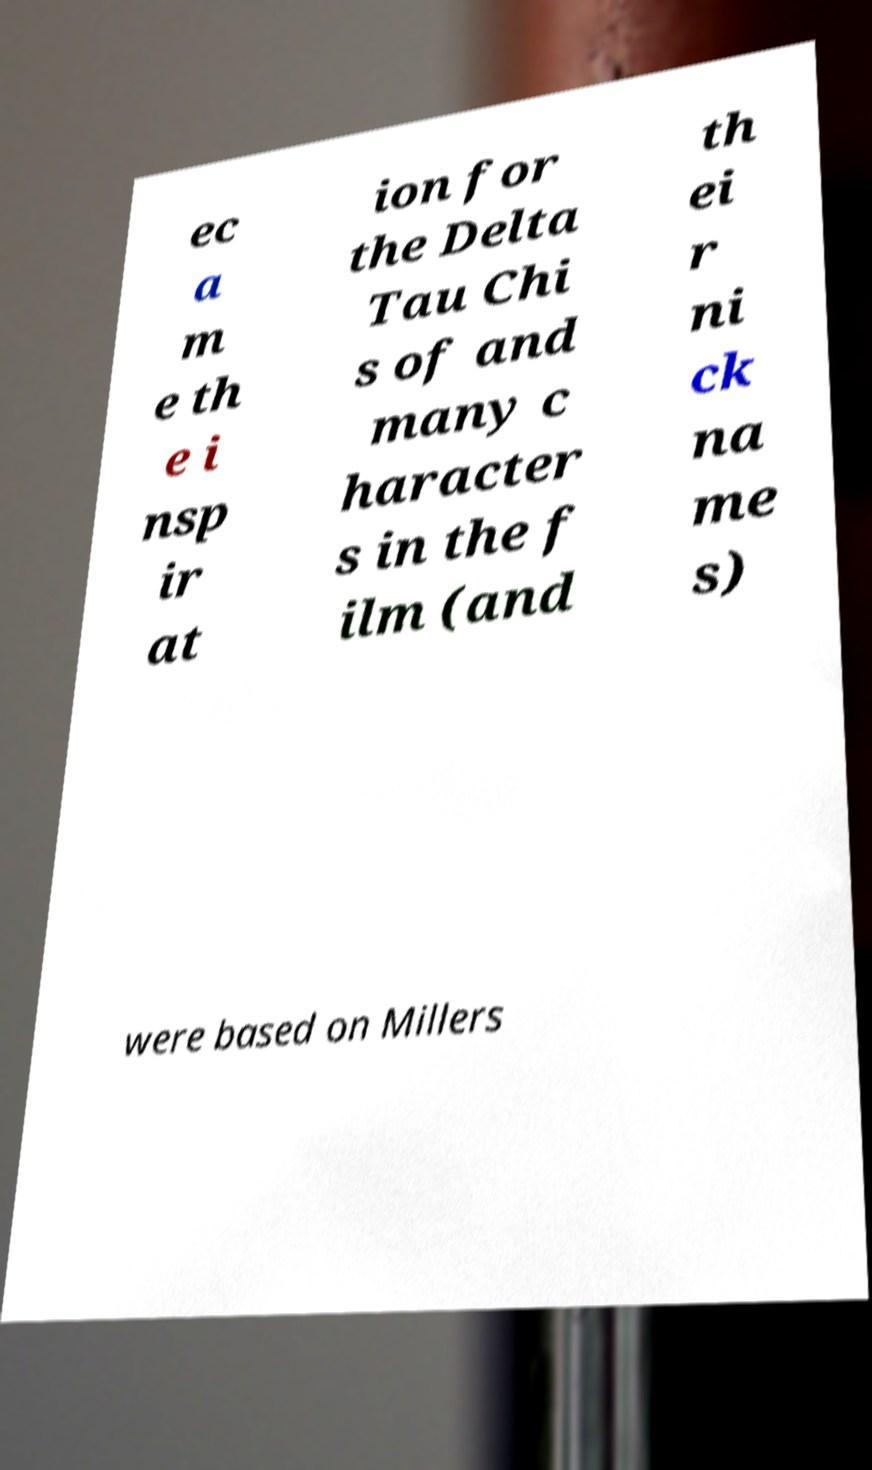Please identify and transcribe the text found in this image. ec a m e th e i nsp ir at ion for the Delta Tau Chi s of and many c haracter s in the f ilm (and th ei r ni ck na me s) were based on Millers 